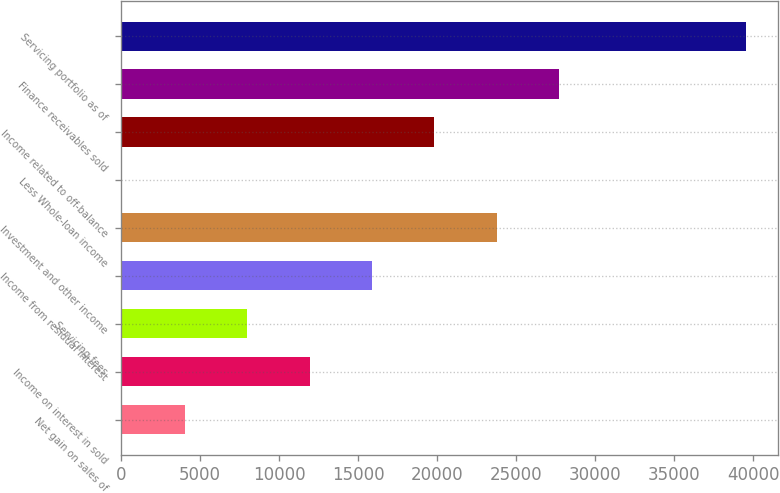Convert chart to OTSL. <chart><loc_0><loc_0><loc_500><loc_500><bar_chart><fcel>Net gain on sales of<fcel>Income on interest in sold<fcel>Servicing fees<fcel>Income from residual interest<fcel>Investment and other income<fcel>Less Whole-loan income<fcel>Income related to off-balance<fcel>Finance receivables sold<fcel>Servicing portfolio as of<nl><fcel>4039.2<fcel>11935.6<fcel>7987.4<fcel>15883.8<fcel>23780.2<fcel>91<fcel>19832<fcel>27728.4<fcel>39573<nl></chart> 